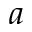Convert formula to latex. <formula><loc_0><loc_0><loc_500><loc_500>a</formula> 